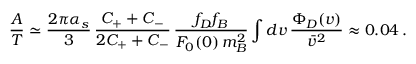<formula> <loc_0><loc_0><loc_500><loc_500>\frac { A } { T } \simeq \frac { 2 \pi \alpha _ { s } } { 3 } \, \frac { C _ { + } + C _ { - } } { 2 C _ { + } + C _ { - } } \, \frac { f _ { D } f _ { B } } { F _ { 0 } ( 0 ) \, m _ { B } ^ { 2 } } \int d v \, \frac { \Phi _ { D } ( v ) } { \bar { v } ^ { 2 } } \approx 0 . 0 4 \, .</formula> 